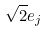Convert formula to latex. <formula><loc_0><loc_0><loc_500><loc_500>\sqrt { 2 } e _ { j }</formula> 